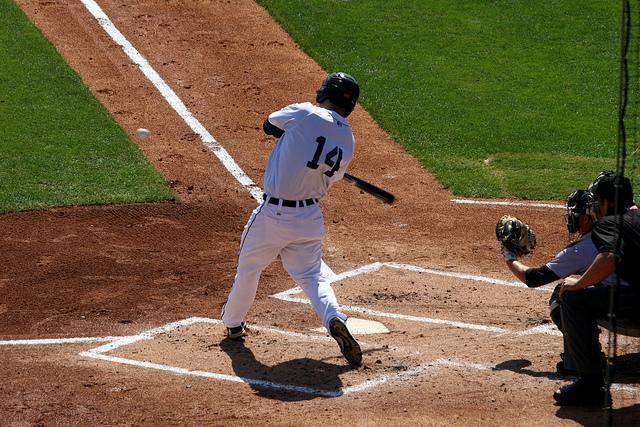How many people can be seen?
Give a very brief answer. 3. How many glass bottles are on the ledge behind the stove?
Give a very brief answer. 0. 